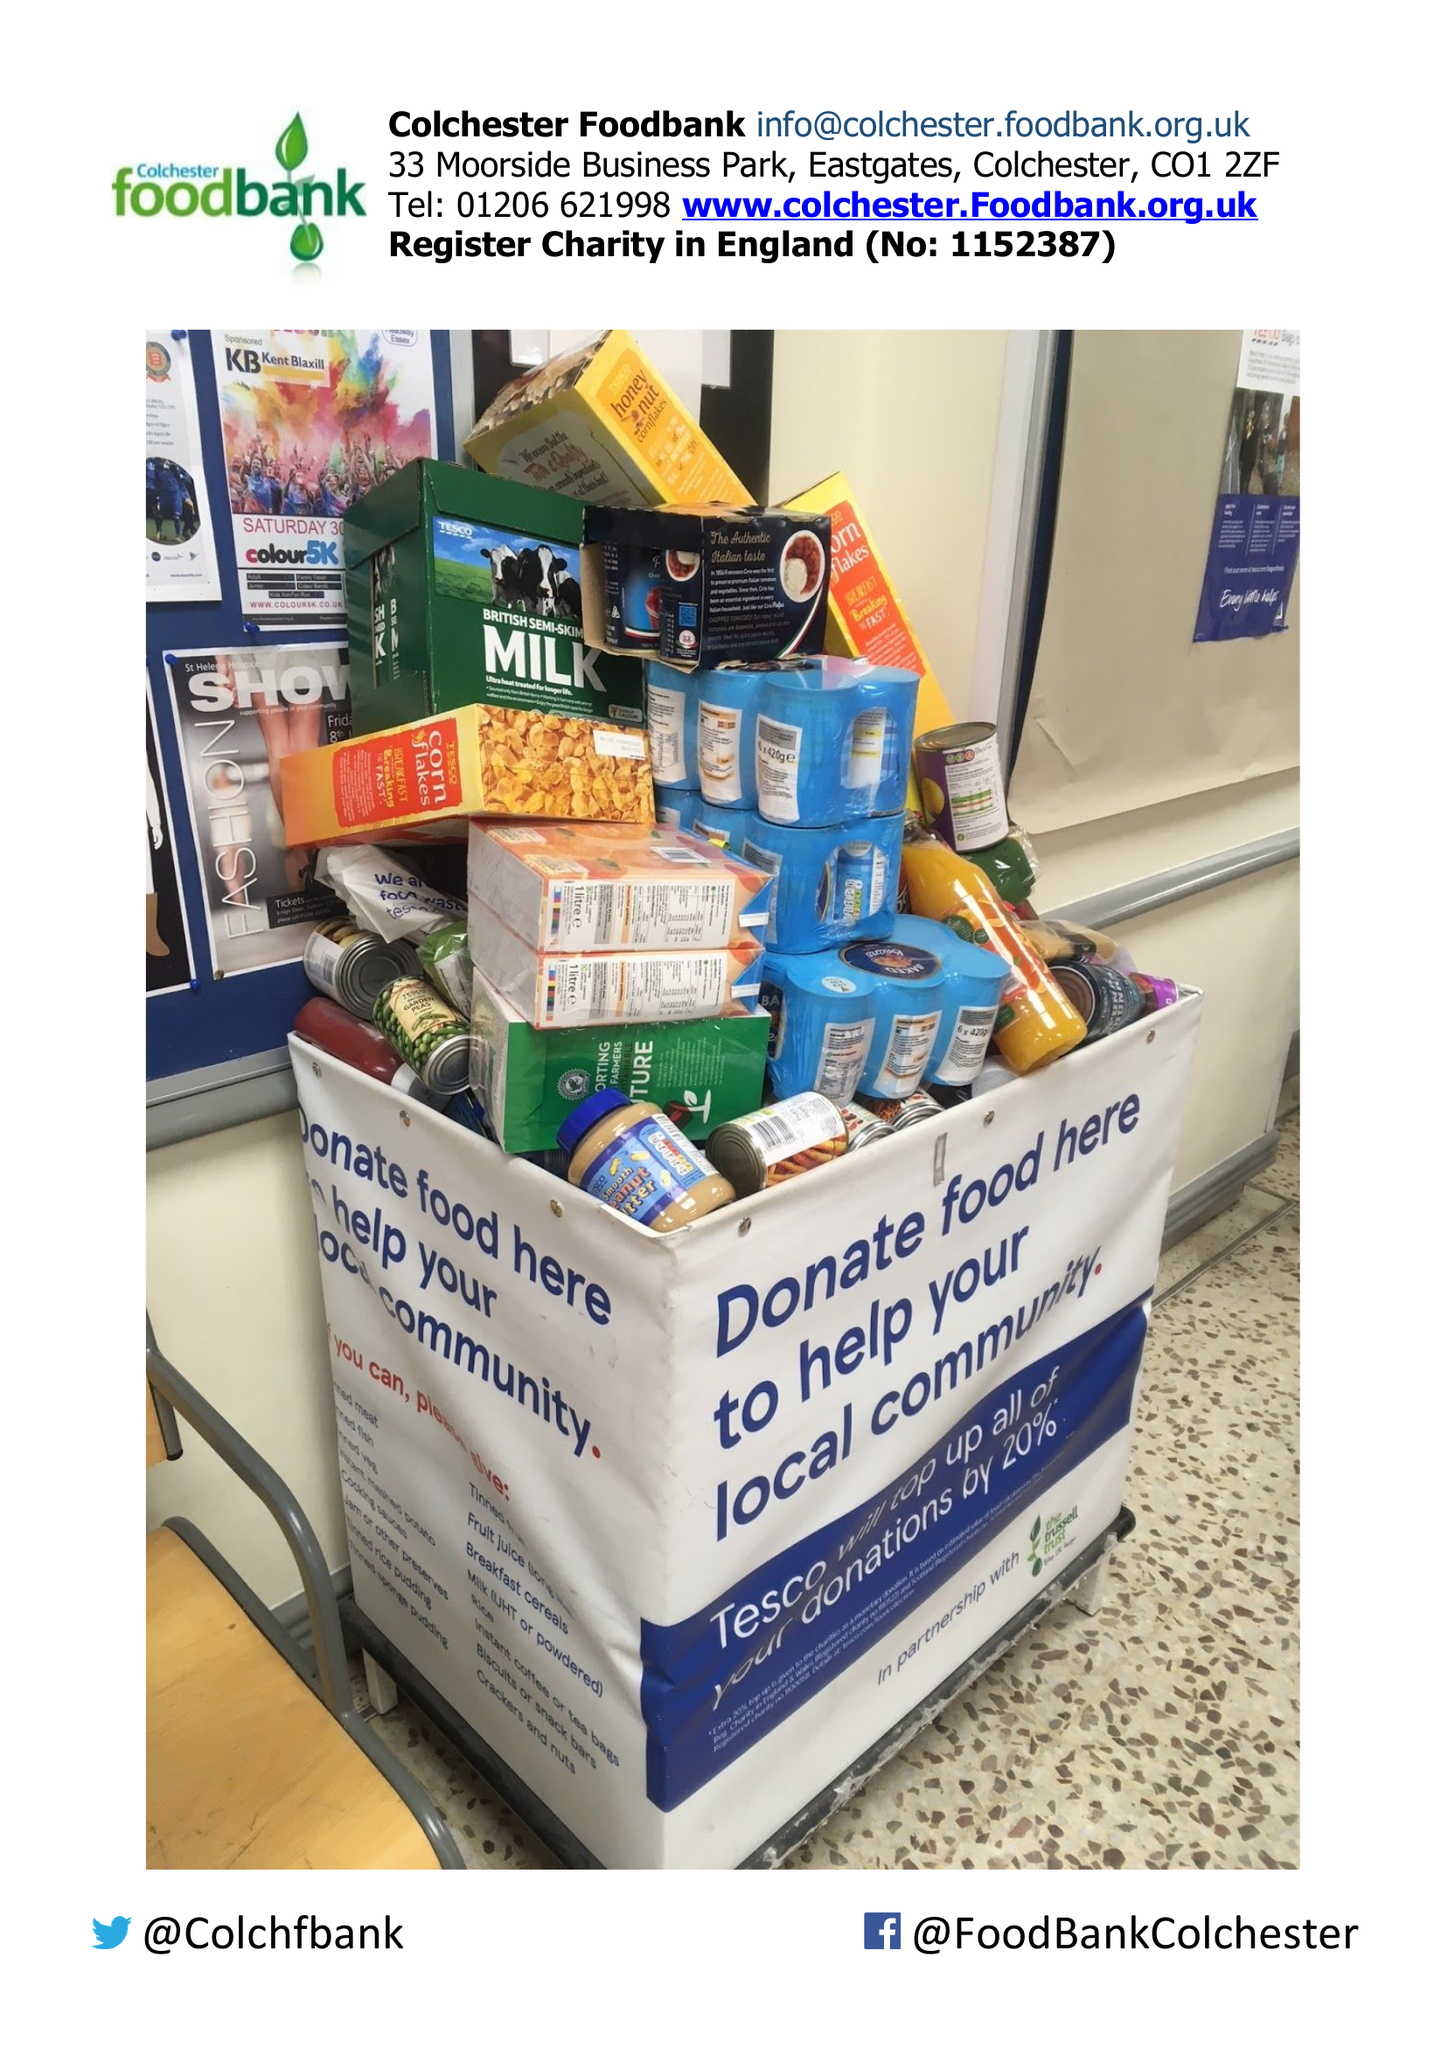What is the value for the charity_name?
Answer the question using a single word or phrase. Colchester Foodbank 